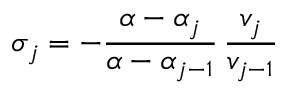Convert formula to latex. <formula><loc_0><loc_0><loc_500><loc_500>\sigma _ { j } = - \frac { \alpha - \alpha _ { j } } { \alpha - \alpha _ { j - 1 } } \, \frac { v _ { j } } { v _ { j - 1 } }</formula> 